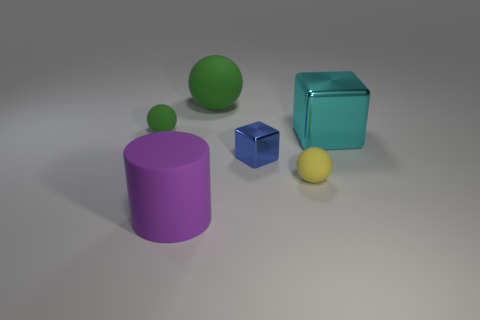Add 1 small yellow matte cubes. How many objects exist? 7 Subtract all blocks. How many objects are left? 4 Subtract 0 green cylinders. How many objects are left? 6 Subtract all large purple objects. Subtract all tiny yellow rubber objects. How many objects are left? 4 Add 5 cylinders. How many cylinders are left? 6 Add 5 small things. How many small things exist? 8 